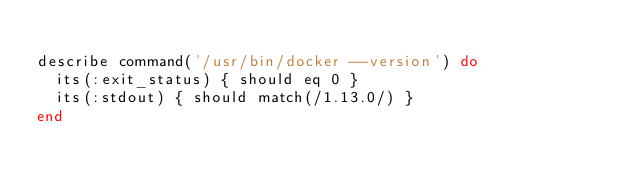<code> <loc_0><loc_0><loc_500><loc_500><_Ruby_>
describe command('/usr/bin/docker --version') do
  its(:exit_status) { should eq 0 }
  its(:stdout) { should match(/1.13.0/) }
end
</code> 